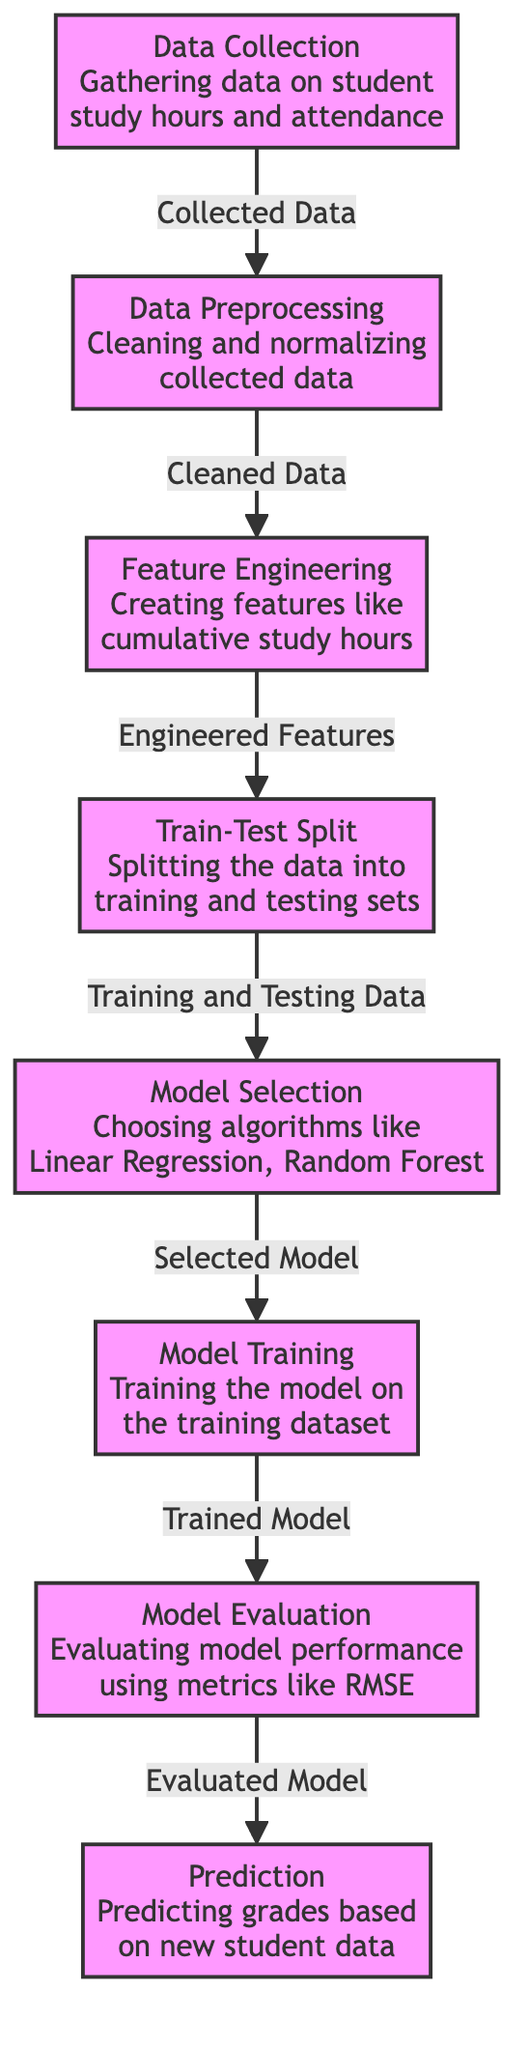What is the first step in the diagram? The first node represents "Data Collection," which is the starting point for gathering data on student study hours and attendance.
Answer: Data Collection How many nodes are present in the diagram? The diagram contains eight nodes, which are distinct steps in the predictive analysis process.
Answer: Eight Which step follows "Data Preprocessing"? The step that comes after "Data Preprocessing" is "Feature Engineering," where features like cumulative study hours are created.
Answer: Feature Engineering What is the relationship between "Model Selection" and "Model Training"? "Model Selection" precedes "Model Training," indicating that a model must be selected before it can be trained on the training dataset.
Answer: Model Selection precedes Model Training Which evaluation metric is mentioned in "Model Evaluation"? The evaluation metric specified in "Model Evaluation" is RMSE (Root Mean Square Error), used to assess model performance.
Answer: RMSE What is created in the "Feature Engineering" step? In "Feature Engineering," features such as cumulative study hours are created to enhance the dataset for model training.
Answer: Cumulative study hours How does the output of "Model Evaluation" affect the next step? The output of "Model Evaluation," which assesses the model's performance, directly impacts the prediction step by determining the quality of the model used for predictions.
Answer: It impacts the prediction step What is the final output of the diagram's process? The final output represented in the diagram is "Prediction," where grades are predicted based on new student data.
Answer: Prediction 